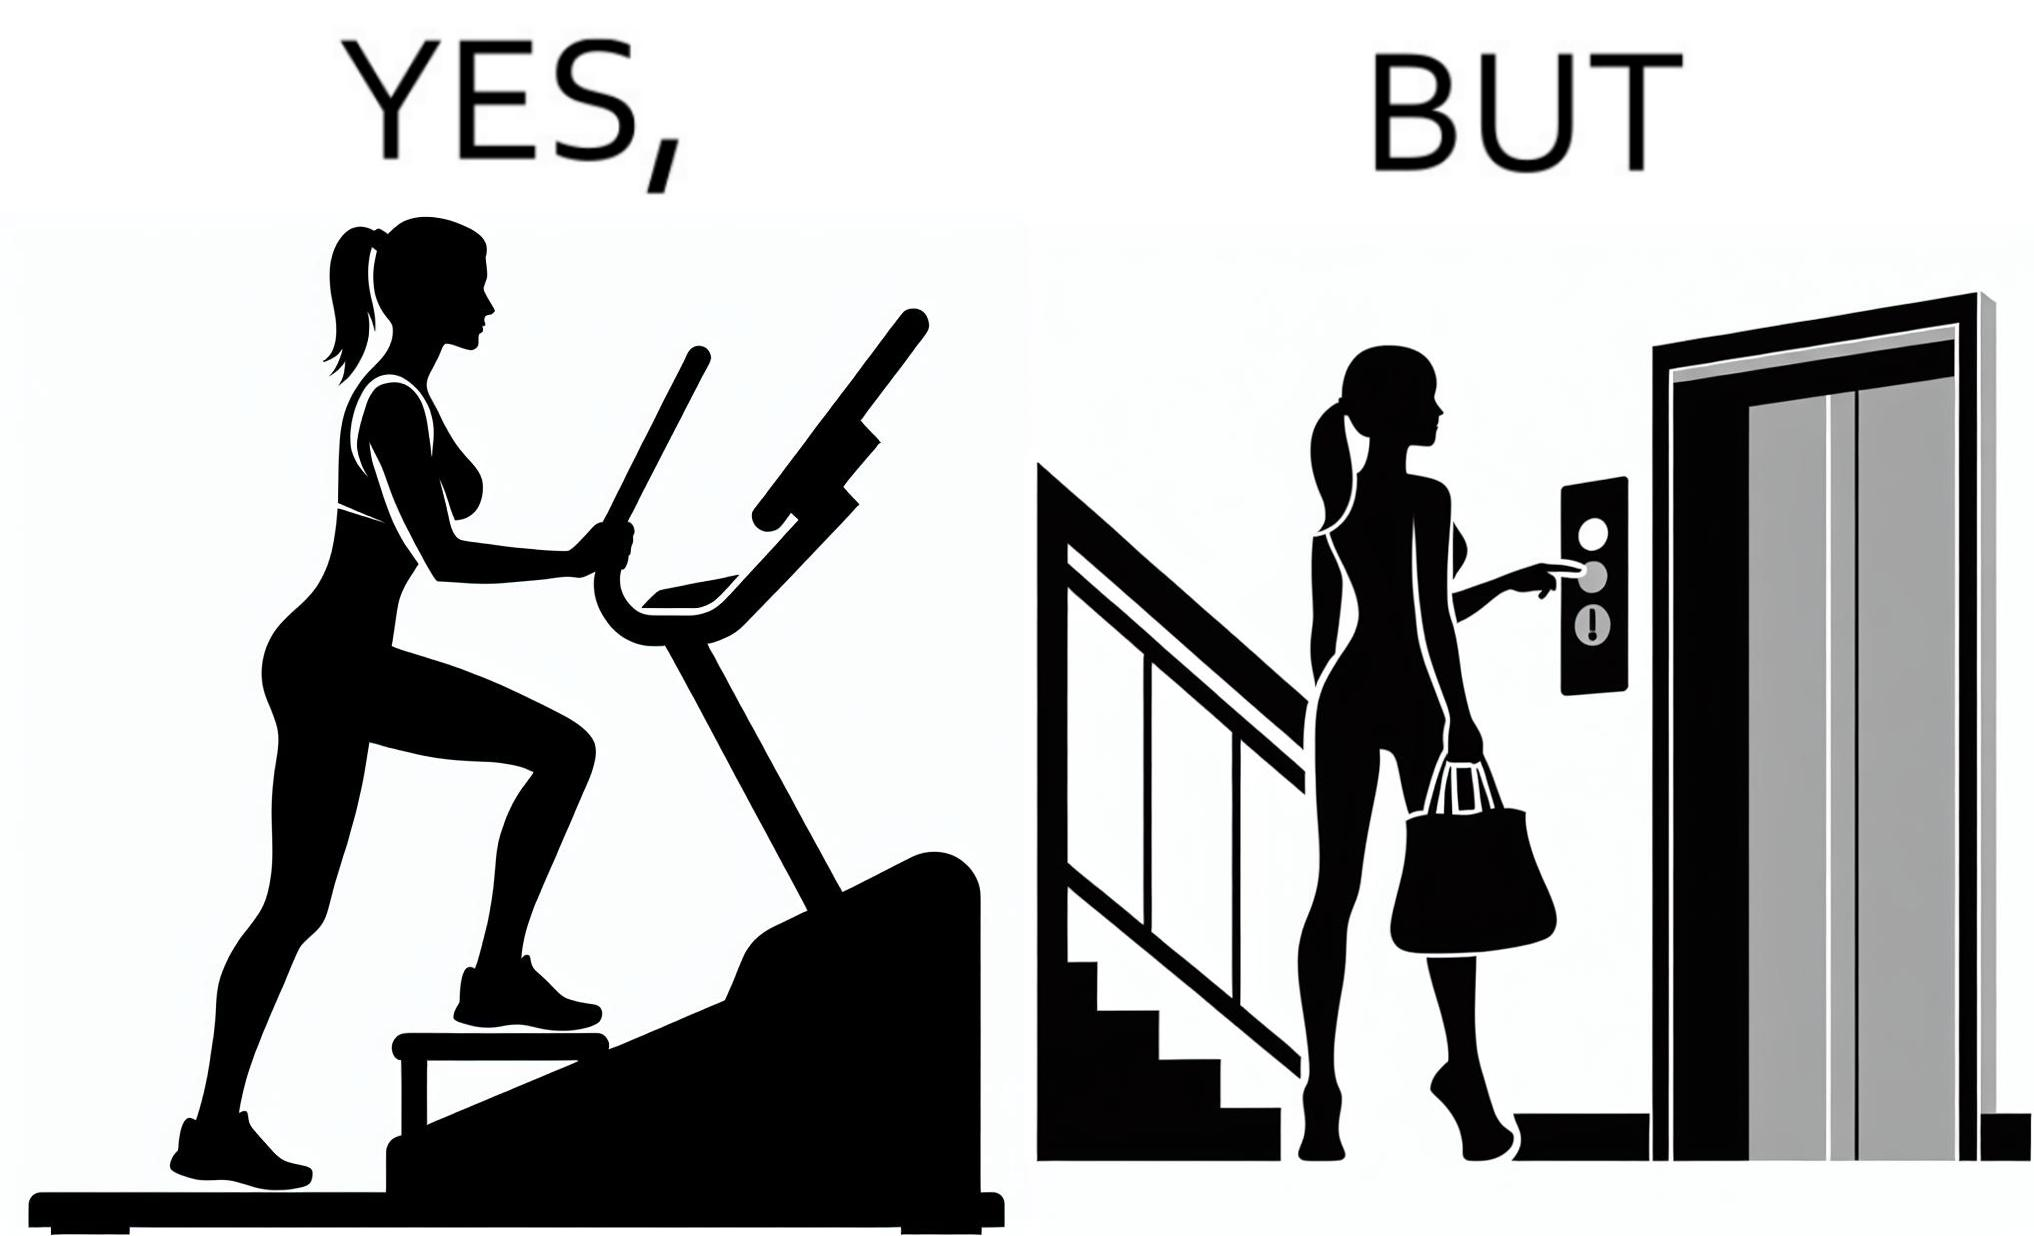Compare the left and right sides of this image. In the left part of the image: a woman is seen using the stair climber machine at some gym In the right part of the image: a woman calling for the lift to avoid climbing up the stairs for going to the gym 